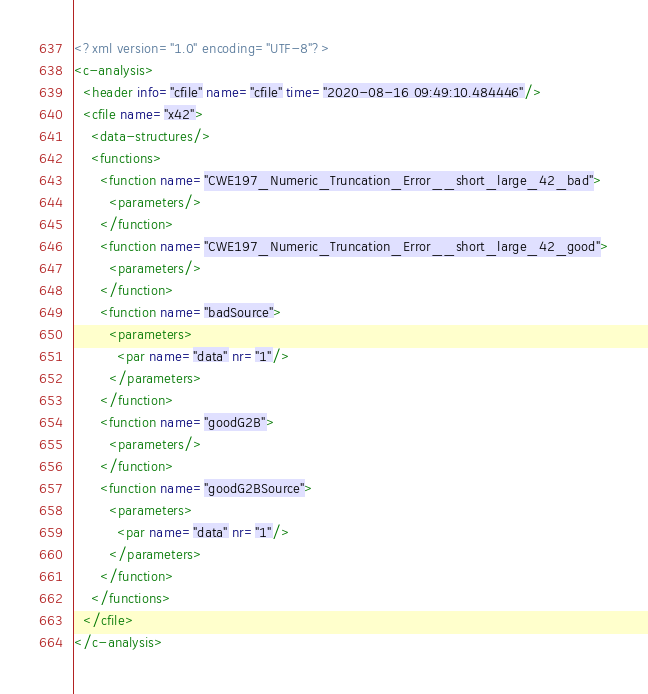Convert code to text. <code><loc_0><loc_0><loc_500><loc_500><_XML_><?xml version="1.0" encoding="UTF-8"?>
<c-analysis>
  <header info="cfile" name="cfile" time="2020-08-16 09:49:10.484446"/>
  <cfile name="x42">
    <data-structures/>
    <functions>
      <function name="CWE197_Numeric_Truncation_Error__short_large_42_bad">
        <parameters/>
      </function>
      <function name="CWE197_Numeric_Truncation_Error__short_large_42_good">
        <parameters/>
      </function>
      <function name="badSource">
        <parameters>
          <par name="data" nr="1"/>
        </parameters>
      </function>
      <function name="goodG2B">
        <parameters/>
      </function>
      <function name="goodG2BSource">
        <parameters>
          <par name="data" nr="1"/>
        </parameters>
      </function>
    </functions>
  </cfile>
</c-analysis>
</code> 